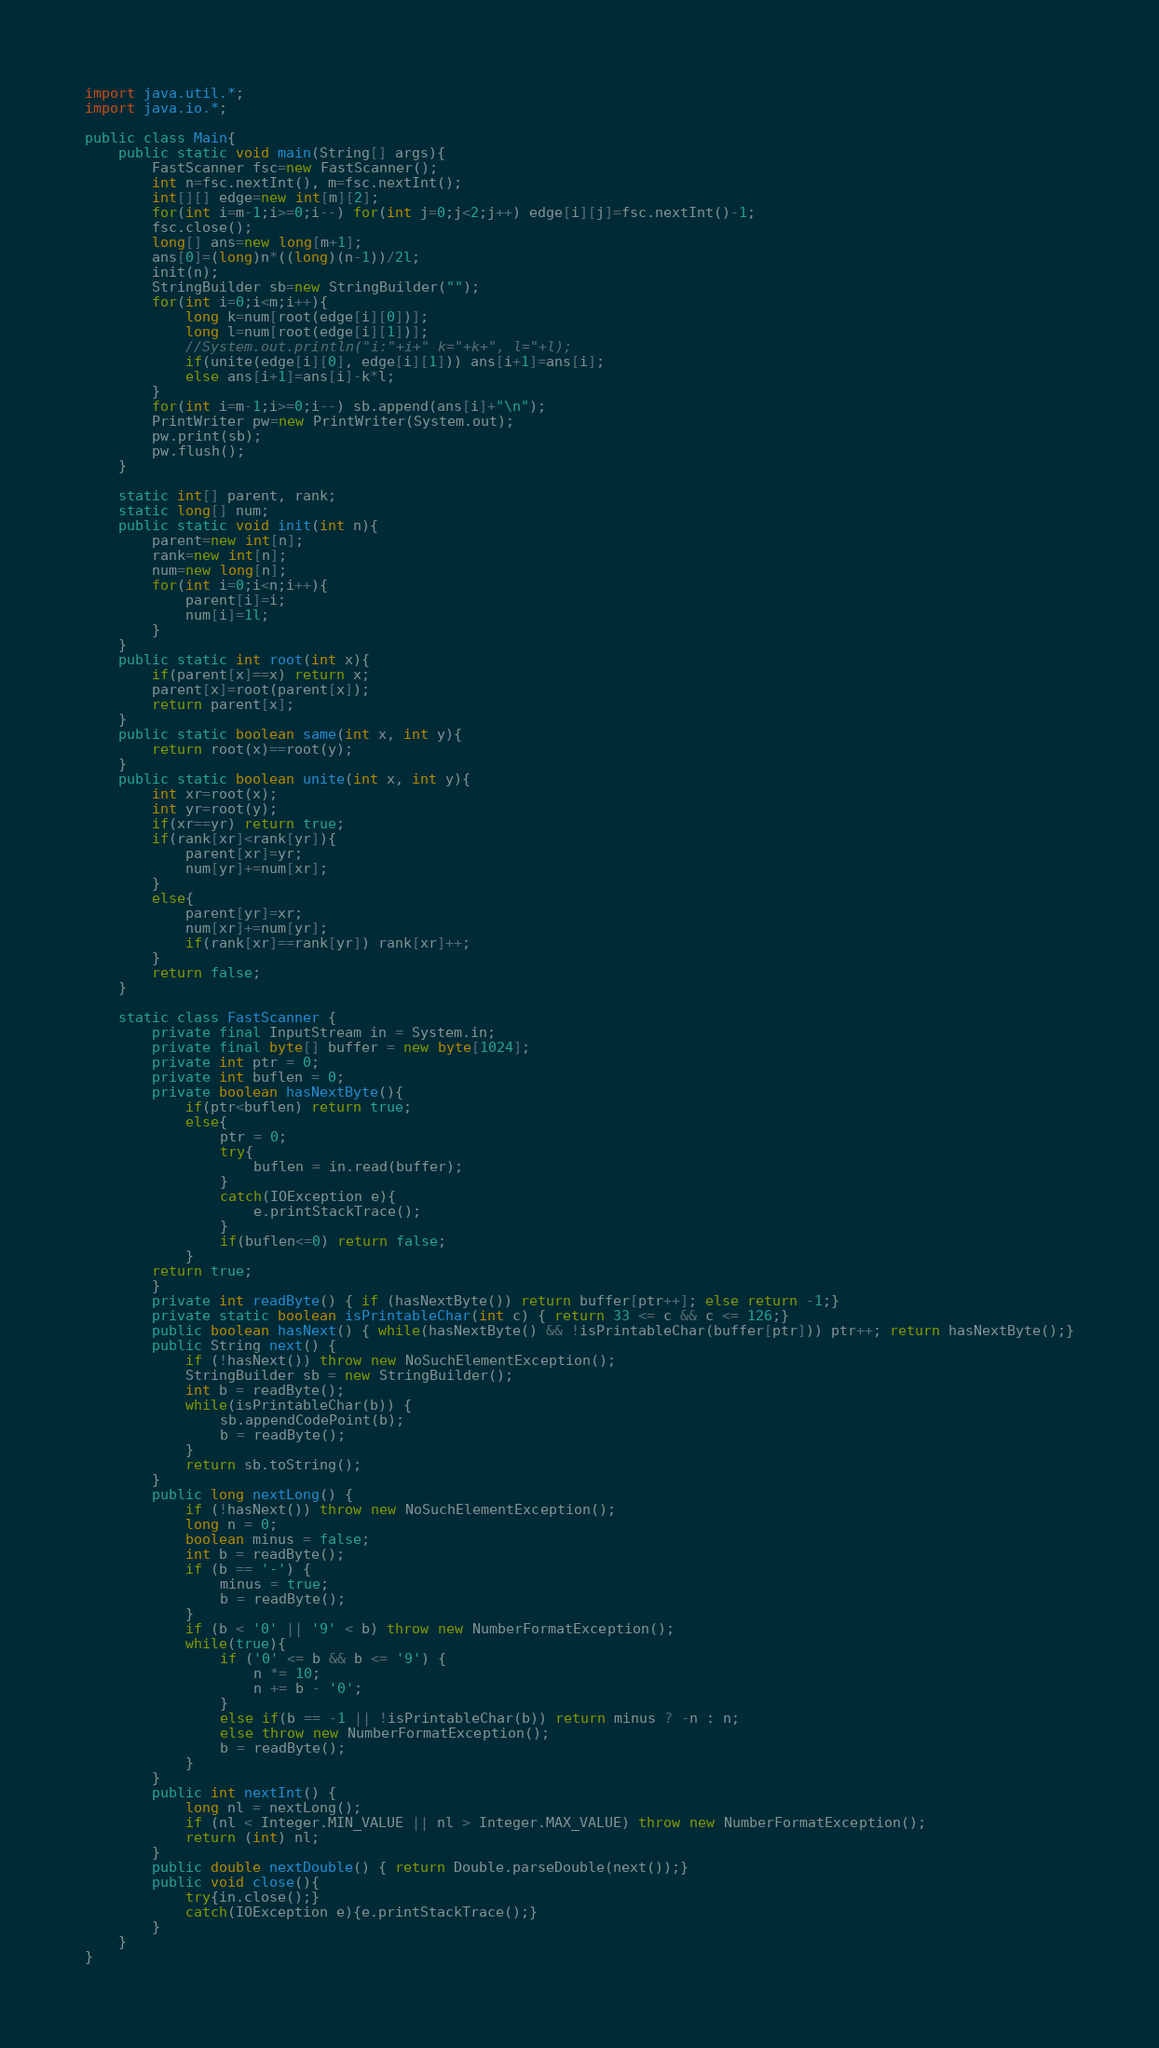Convert code to text. <code><loc_0><loc_0><loc_500><loc_500><_Java_>import java.util.*;
import java.io.*;

public class Main{
    public static void main(String[] args){
        FastScanner fsc=new FastScanner();
        int n=fsc.nextInt(), m=fsc.nextInt();
        int[][] edge=new int[m][2];
        for(int i=m-1;i>=0;i--) for(int j=0;j<2;j++) edge[i][j]=fsc.nextInt()-1;
        fsc.close();
        long[] ans=new long[m+1];
        ans[0]=(long)n*((long)(n-1))/2l;
        init(n);
        StringBuilder sb=new StringBuilder("");
        for(int i=0;i<m;i++){
            long k=num[root(edge[i][0])];
            long l=num[root(edge[i][1])];
            //System.out.println("i:"+i+" k="+k+", l="+l);
            if(unite(edge[i][0], edge[i][1])) ans[i+1]=ans[i];
            else ans[i+1]=ans[i]-k*l;
        }
        for(int i=m-1;i>=0;i--) sb.append(ans[i]+"\n");
        PrintWriter pw=new PrintWriter(System.out);
        pw.print(sb);
        pw.flush();
    }

    static int[] parent, rank;
    static long[] num;
    public static void init(int n){
        parent=new int[n];
        rank=new int[n];
        num=new long[n];
        for(int i=0;i<n;i++){
            parent[i]=i;
            num[i]=1l;
        }
    }
    public static int root(int x){
        if(parent[x]==x) return x;
        parent[x]=root(parent[x]);
        return parent[x];
    }
    public static boolean same(int x, int y){
        return root(x)==root(y);
    }
    public static boolean unite(int x, int y){
        int xr=root(x);
        int yr=root(y);
        if(xr==yr) return true;
        if(rank[xr]<rank[yr]){
            parent[xr]=yr;
            num[yr]+=num[xr];
        }
        else{
            parent[yr]=xr;
            num[xr]+=num[yr];
            if(rank[xr]==rank[yr]) rank[xr]++;
        }
        return false;
    }

    static class FastScanner {
        private final InputStream in = System.in;
        private final byte[] buffer = new byte[1024];
        private int ptr = 0;
        private int buflen = 0;
        private boolean hasNextByte(){
            if(ptr<buflen) return true;
            else{
                ptr = 0;
                try{
                    buflen = in.read(buffer);
                }
                catch(IOException e){
                    e.printStackTrace();
                }
                if(buflen<=0) return false;
            }
        return true;
        }
        private int readByte() { if (hasNextByte()) return buffer[ptr++]; else return -1;}
        private static boolean isPrintableChar(int c) { return 33 <= c && c <= 126;}
        public boolean hasNext() { while(hasNextByte() && !isPrintableChar(buffer[ptr])) ptr++; return hasNextByte();}
        public String next() {
            if (!hasNext()) throw new NoSuchElementException();
            StringBuilder sb = new StringBuilder();
            int b = readByte();
            while(isPrintableChar(b)) {
                sb.appendCodePoint(b);
                b = readByte();
            }
            return sb.toString();
        }
        public long nextLong() {
            if (!hasNext()) throw new NoSuchElementException();
            long n = 0;
            boolean minus = false;
            int b = readByte();
            if (b == '-') {
                minus = true;
                b = readByte();
            }
            if (b < '0' || '9' < b) throw new NumberFormatException();
            while(true){
                if ('0' <= b && b <= '9') {
                    n *= 10;
                    n += b - '0';
                }
                else if(b == -1 || !isPrintableChar(b)) return minus ? -n : n;
                else throw new NumberFormatException();
                b = readByte();
            }
        }
        public int nextInt() {
            long nl = nextLong();
            if (nl < Integer.MIN_VALUE || nl > Integer.MAX_VALUE) throw new NumberFormatException();
            return (int) nl;
        }
        public double nextDouble() { return Double.parseDouble(next());}
        public void close(){
            try{in.close();}
            catch(IOException e){e.printStackTrace();}
        }
    }
}</code> 